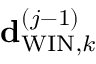Convert formula to latex. <formula><loc_0><loc_0><loc_500><loc_500>{ d } _ { W I N , k } ^ { \left ( j - 1 \right ) }</formula> 